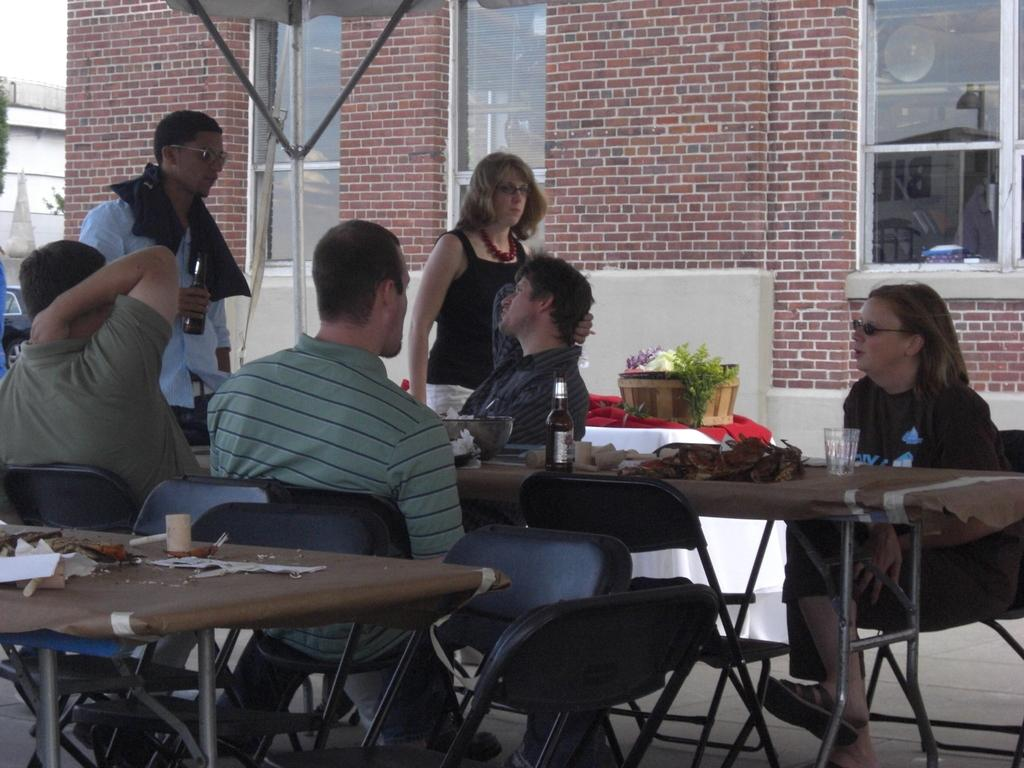What are the people in the image doing? The people in the image are sitting on chairs. Are there any standing persons in the image? Yes, two persons are standing. What can be seen on the table in the image? There is a glass and a wine-bottle on the table. What is visible in the background of the image? There is a building, a window, and reddish bricks in the background. How many icicles are hanging from the window in the image? There are no icicles present in the image; the window is not shown with any icicles. What type of birds can be seen flying near the building in the image? There are no birds visible in the image; only the building, window, and reddish bricks are present in the background. 